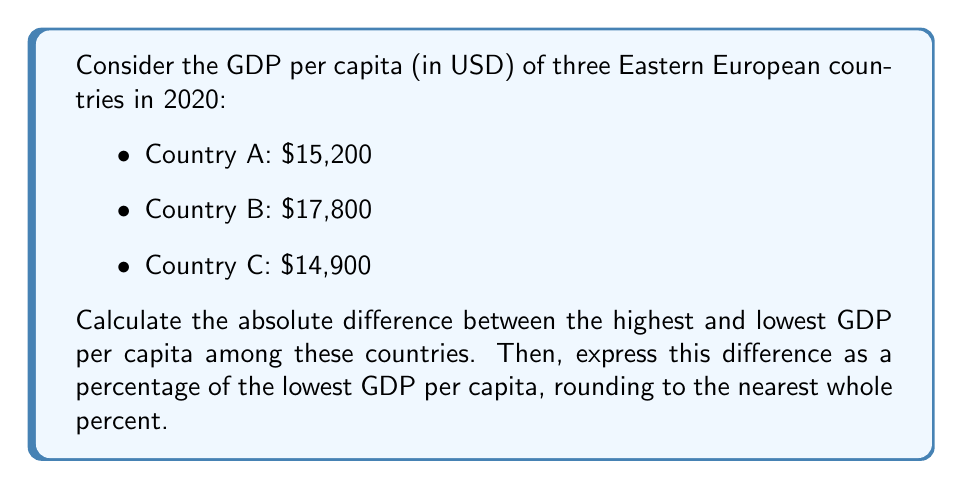Can you answer this question? 1. Identify the highest and lowest GDP per capita:
   Highest: Country B with $17,800
   Lowest: Country C with $14,900

2. Calculate the absolute difference:
   $17,800 - $14,900 = $2,900

3. Express the difference as a percentage of the lowest GDP per capita:
   $$\text{Percentage} = \frac{\text{Difference}}{\text{Lowest GDP}} \times 100\%$$
   $$= \frac{2,900}{14,900} \times 100\%$$
   $$\approx 0.1946 \times 100\%$$
   $$= 19.46\%$$

4. Round to the nearest whole percent:
   19.46% rounds to 19%
Answer: 19% 